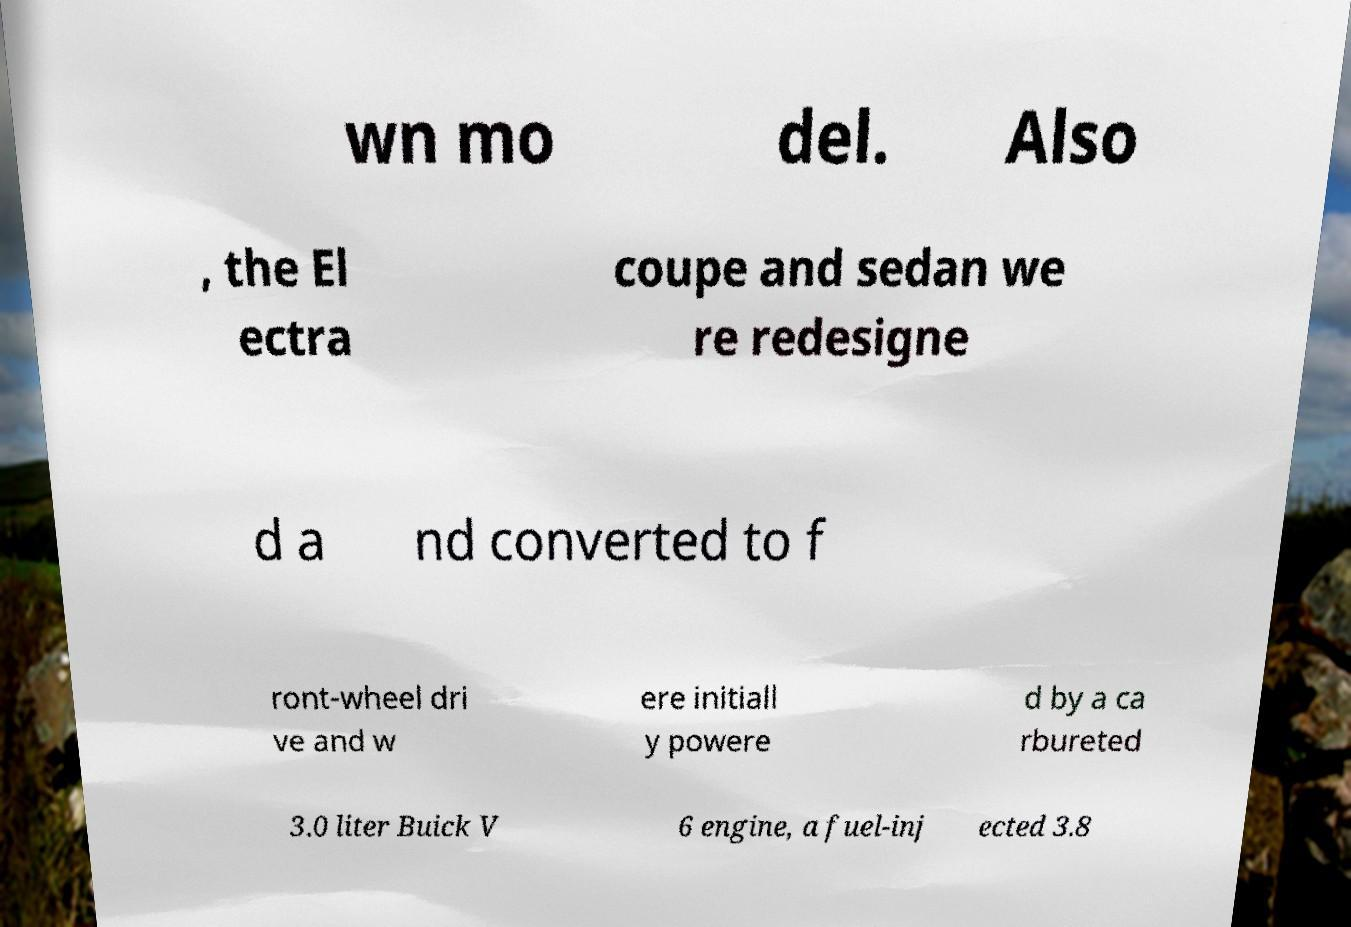For documentation purposes, I need the text within this image transcribed. Could you provide that? wn mo del. Also , the El ectra coupe and sedan we re redesigne d a nd converted to f ront-wheel dri ve and w ere initiall y powere d by a ca rbureted 3.0 liter Buick V 6 engine, a fuel-inj ected 3.8 